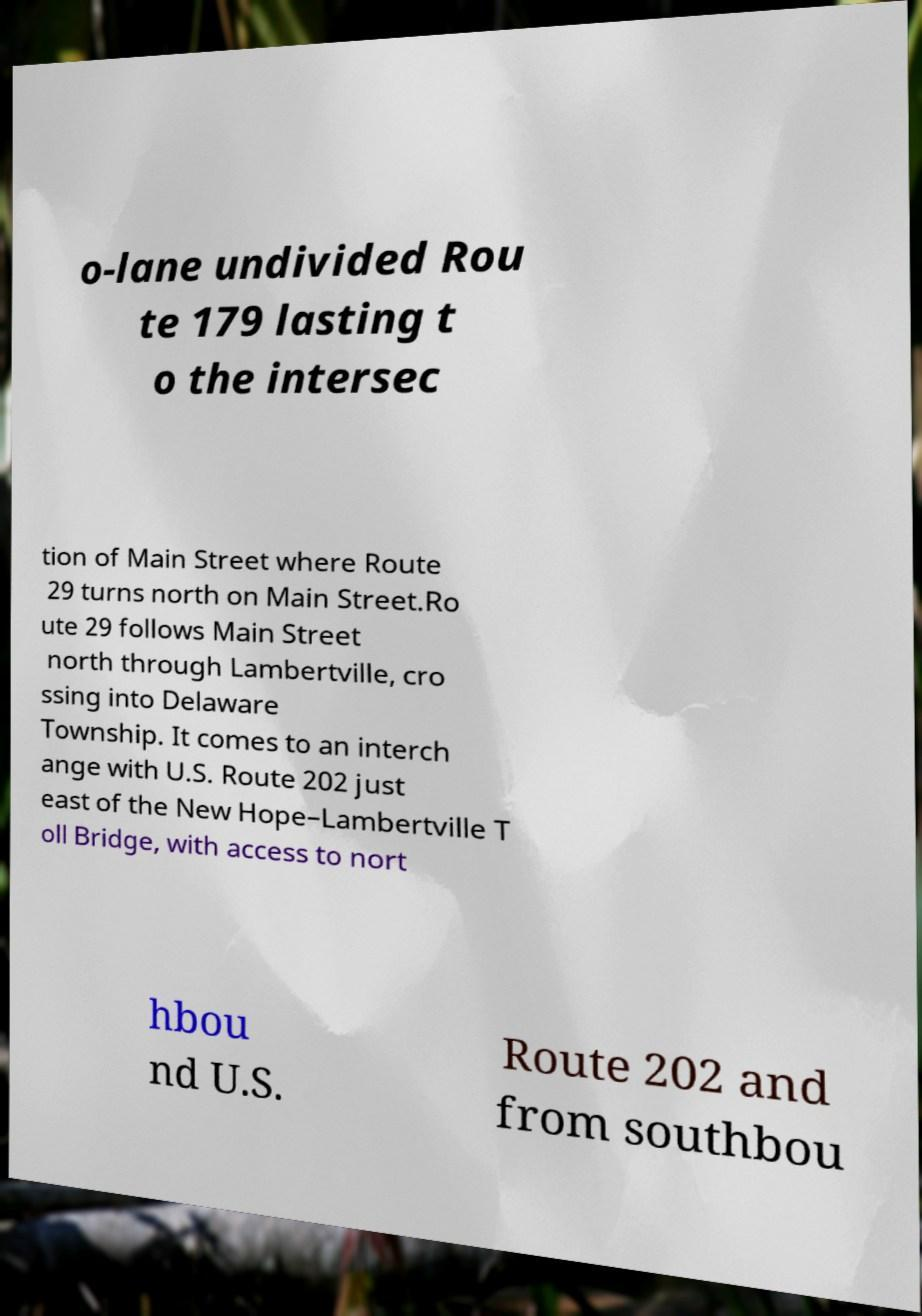For documentation purposes, I need the text within this image transcribed. Could you provide that? o-lane undivided Rou te 179 lasting t o the intersec tion of Main Street where Route 29 turns north on Main Street.Ro ute 29 follows Main Street north through Lambertville, cro ssing into Delaware Township. It comes to an interch ange with U.S. Route 202 just east of the New Hope–Lambertville T oll Bridge, with access to nort hbou nd U.S. Route 202 and from southbou 